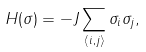<formula> <loc_0><loc_0><loc_500><loc_500>H ( \sigma ) = - J \sum _ { \langle i , j \rangle } \sigma _ { i } \sigma _ { j } ,</formula> 